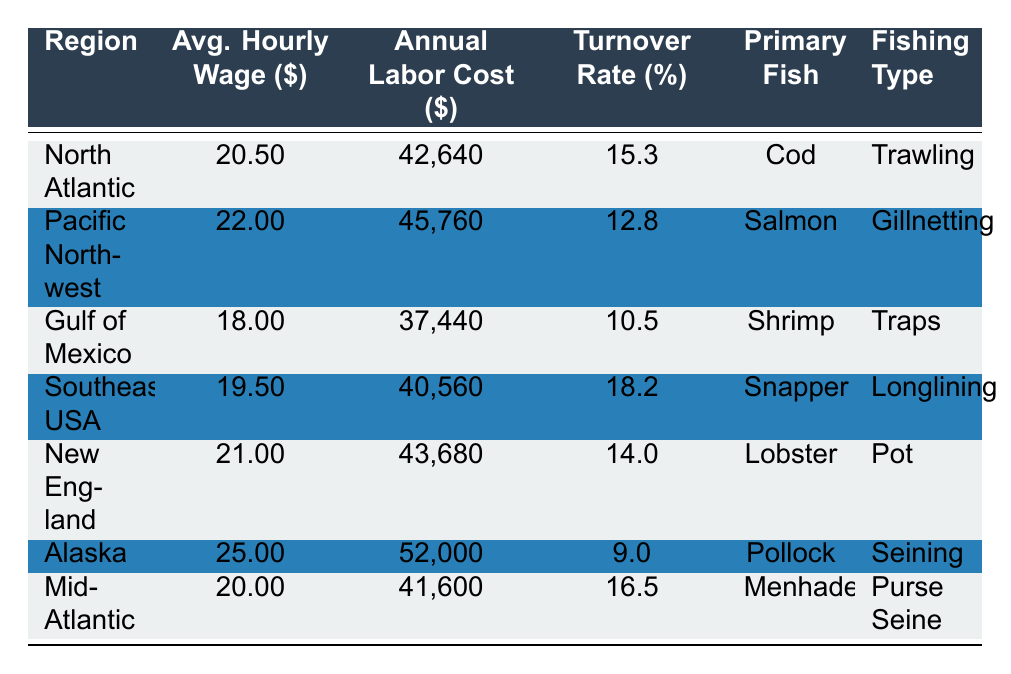What is the average hourly wage in the Gulf of Mexico? The table shows that the average hourly wage in the Gulf of Mexico is listed as 18.00.
Answer: 18.00 Which region has the highest employee turnover rate? By comparing the turnover rates in the table, Southeast USA has the highest rate at 18.2.
Answer: Southeast USA What is the total annual labor cost for all employees in the North Atlantic region if there are 10 employees? The annual labor cost per employee in the North Atlantic is 42,640. For 10 employees, the total cost is 10 times 42640, which equals 426,400.
Answer: 426,400 Is the average hourly wage in New England higher than that in the Gulf of Mexico? New England's average hourly wage is 21.00, while Gulf of Mexico's is 18.00. Since 21.00 is greater than 18.00, the statement is true.
Answer: Yes What is the average employee turnover rate for regions where the primary fish caught is a type of shellfish? The regions with shellfish as the primary catch are Gulf of Mexico (10.5) and New England (14.0); their average turnover rate is (10.5 + 14.0)/2 = 12.25.
Answer: 12.25 Which fishing type has the lowest annual labor cost per employee? The table indicates that the Gulf of Mexico has an annual labor cost of 37,440 per employee, which is lower than all other regions' costs.
Answer: Traps What is the difference between the average hourly wage in Alaska and the Pacific Northwest? Alaska's average hourly wage is 25.00 and Pacific Northwest is 22.00. Thus, the difference is 25.00 - 22.00 = 3.00.
Answer: 3.00 How many regions have an average hourly wage above 20 dollars? The regions with an hourly wage above 20 dollars are Pacific Northwest (22.00), New England (21.00), and Alaska (25.00). There are 3 regions in total.
Answer: 3 Is the average annual labor cost lower than 40,000 in the Southeast USA? The Southeast USA has an annual labor cost of 40,560, which is higher than 40,000, making the statement false.
Answer: No 